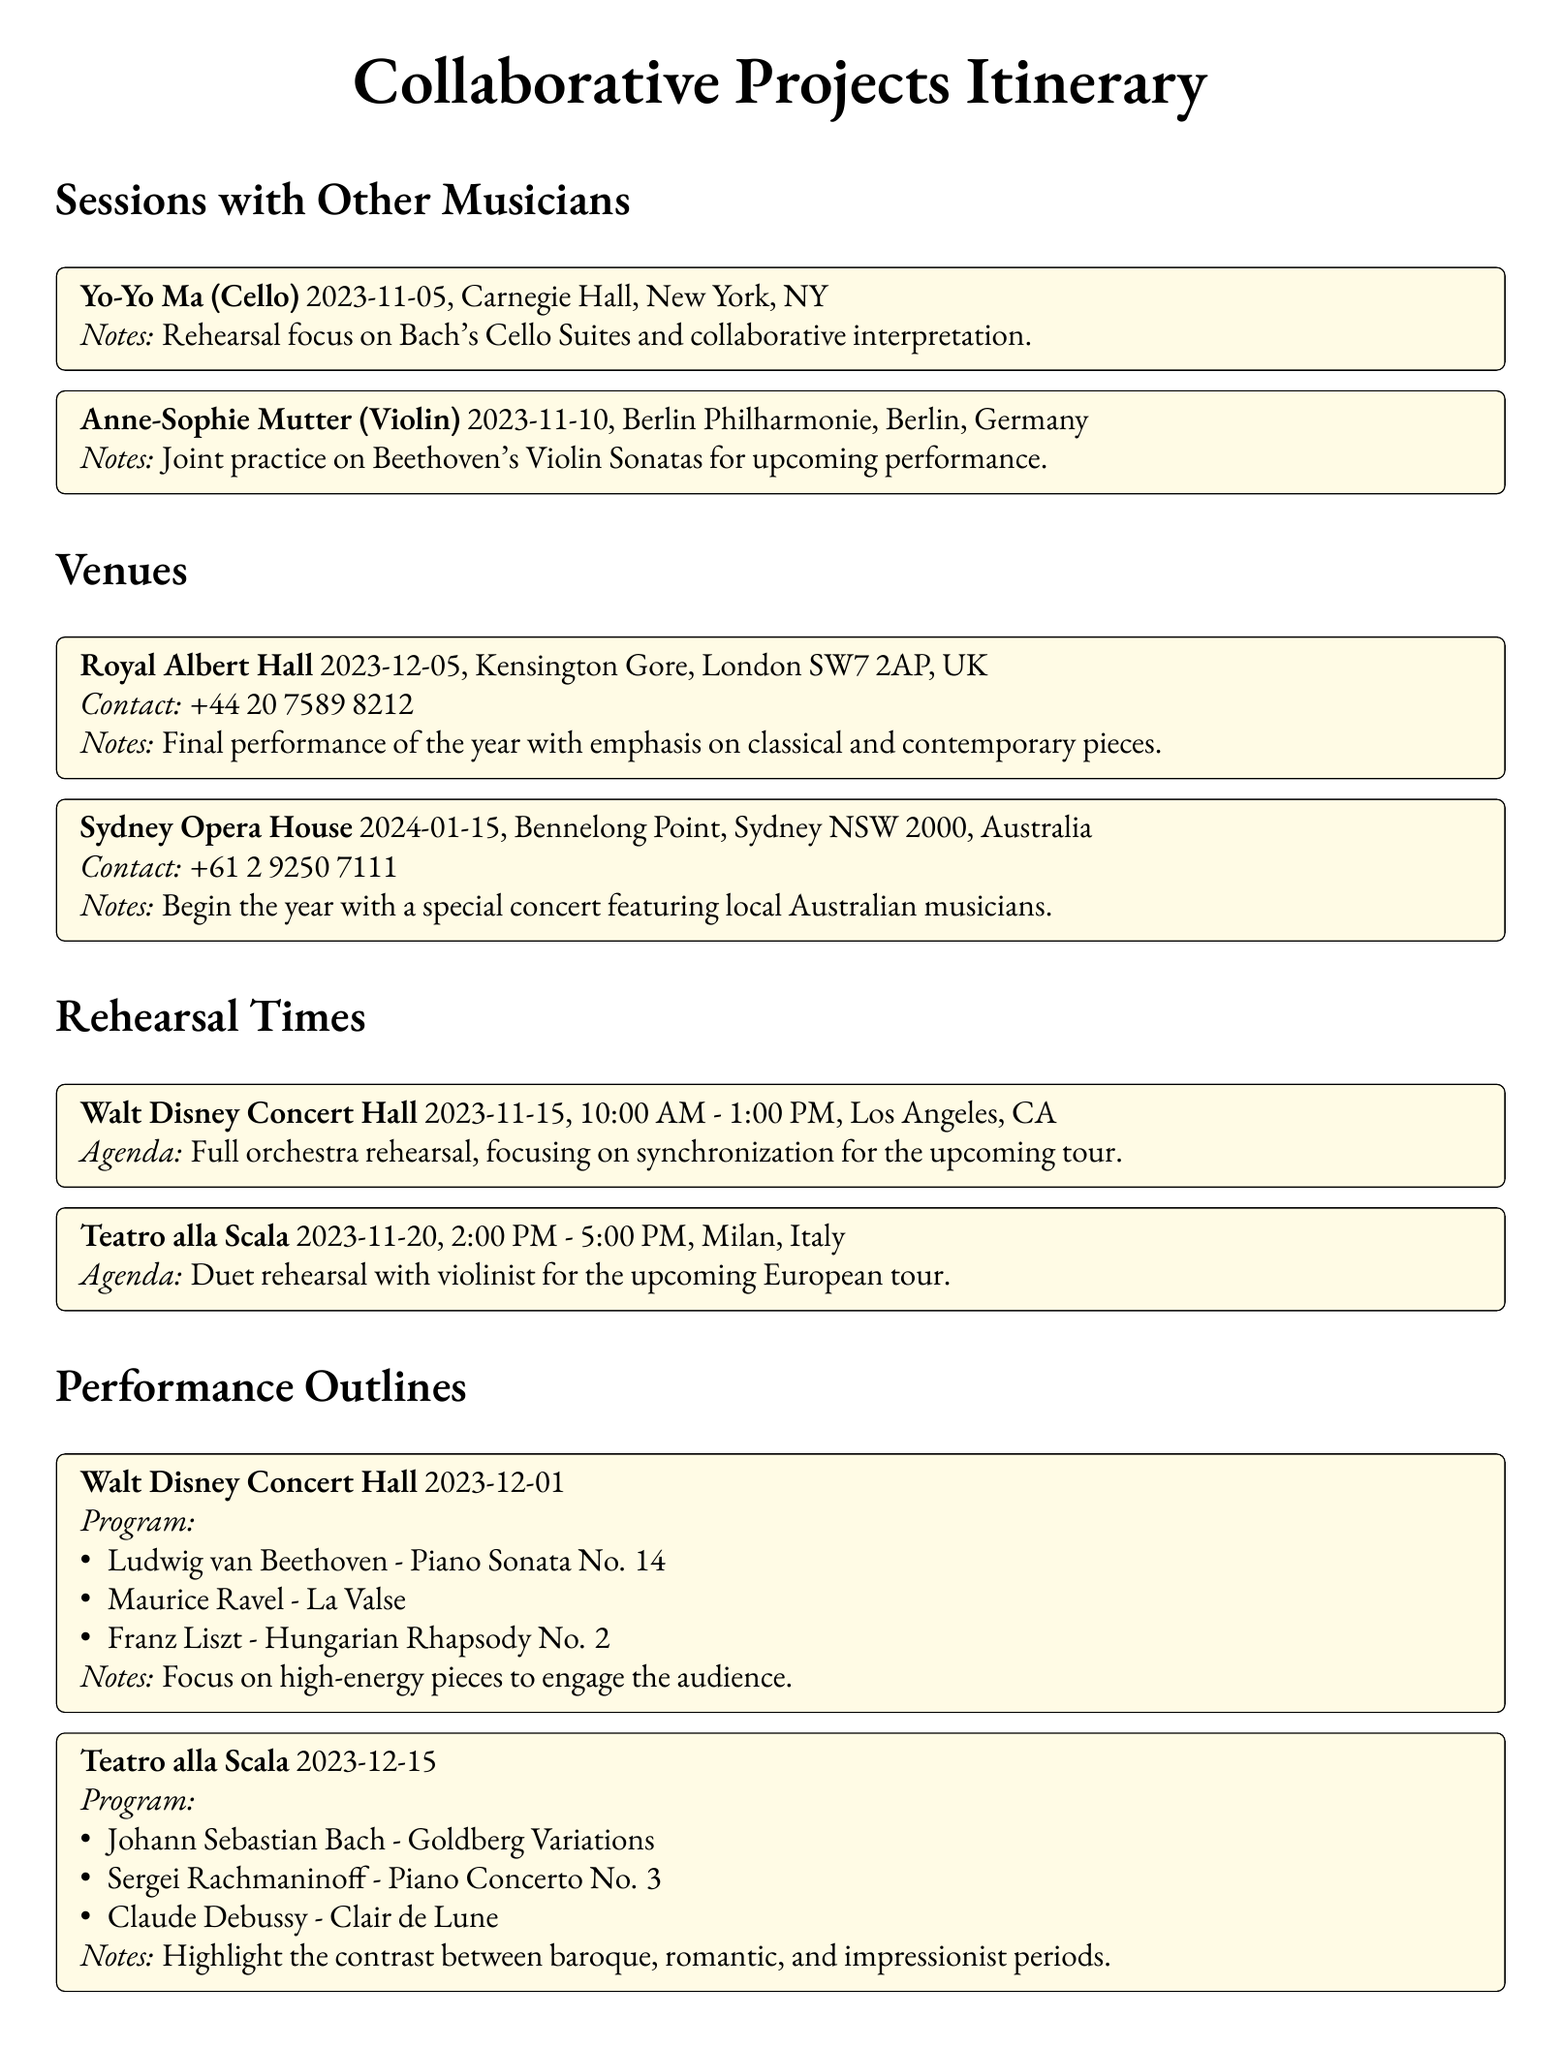What is the date of the session with Yo-Yo Ma? The document specifies the date of the session with Yo-Yo Ma as November 5, 2023.
Answer: November 5, 2023 What is the location of the performance on December 15, 2023? The performance on December 15, 2023, is at Teatro alla Scala in Milan, Italy.
Answer: Teatro alla Scala, Milan, Italy What piece is performed first at the Walt Disney Concert Hall on December 1, 2023? The first piece listed for the performance on December 1, 2023, is Beethoven's Piano Sonata No. 14.
Answer: Beethoven - Piano Sonata No. 14 How long is the rehearsal scheduled for November 20, 2023? The rehearsal on November 20, 2023, is scheduled from 2:00 PM to 5:00 PM, which is three hours long.
Answer: 3 hours Which two venues have performances in December 2023? The venues with performances in December 2023 are Walt Disney Concert Hall and Teatro alla Scala.
Answer: Walt Disney Concert Hall and Teatro alla Scala What is the program focus for the final performance of the year? The final performance of the year emphasizes high-energy pieces according to the program notes.
Answer: High-energy pieces When is the rehearsal at Walt Disney Concert Hall? The rehearsal at Walt Disney Concert Hall is scheduled for November 15, 2023.
Answer: November 15, 2023 Who is the violinist collaborating with on November 10, 2023? The violinist collaborating on November 10, 2023, is Anne-Sophie Mutter.
Answer: Anne-Sophie Mutter 